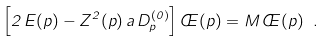<formula> <loc_0><loc_0><loc_500><loc_500>\left [ 2 \, E ( p ) - Z ^ { 2 } ( p ) \, a \, D _ { p } ^ { ( 0 ) } \right ] \phi ( p ) = M \, \phi ( p ) \ .</formula> 